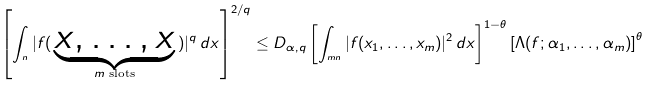<formula> <loc_0><loc_0><loc_500><loc_500>\left [ \int _ { \real ^ { n } } | f ( \, \underbrace { x , \dots , x } _ { m \text { slots} } \, ) | ^ { q } \, d x \right ] ^ { 2 / q } \leq D _ { \alpha , q } \left [ \int _ { \real ^ { m n } } | f ( x _ { 1 } , \dots , x _ { m } ) | ^ { 2 } \, d x \right ] ^ { 1 - \theta } \left [ \Lambda ( f ; \alpha _ { 1 } , \dots , \alpha _ { m } ) \right ] ^ { \theta }</formula> 